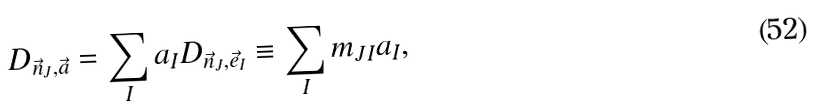<formula> <loc_0><loc_0><loc_500><loc_500>D _ { \vec { n } _ { J } , \vec { a } } = \sum _ { I } a _ { I } D _ { \vec { n } _ { J } , \vec { e } _ { I } } \equiv \sum _ { I } m _ { J I } a _ { I } ,</formula> 